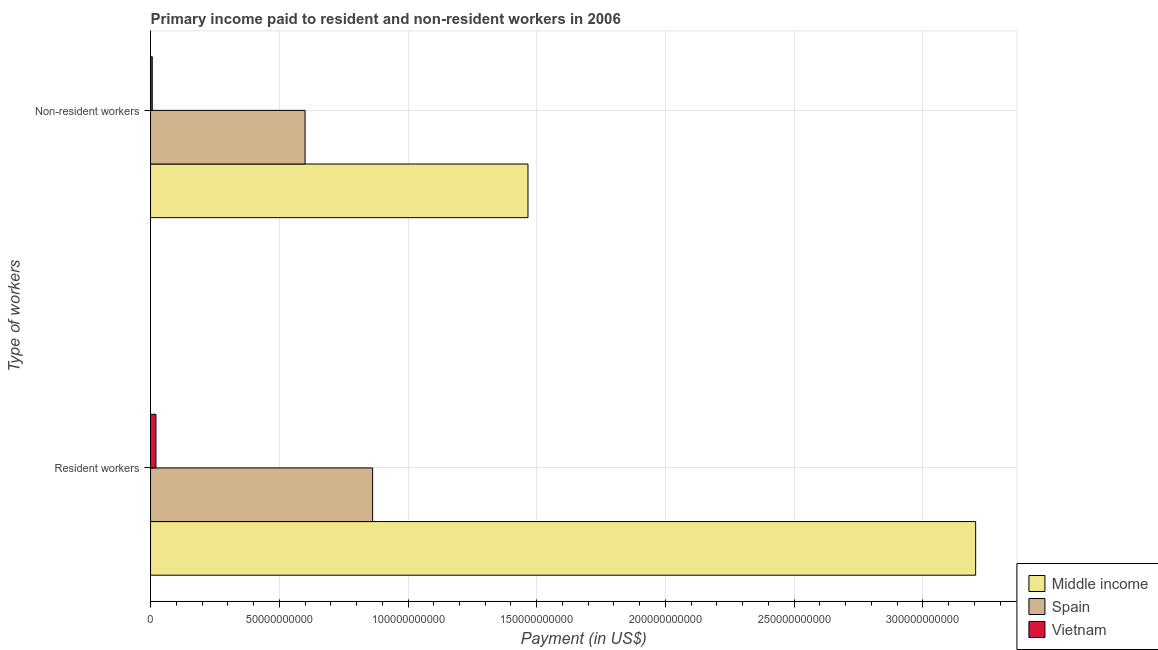How many different coloured bars are there?
Your answer should be very brief. 3. What is the label of the 1st group of bars from the top?
Your answer should be compact. Non-resident workers. What is the payment made to resident workers in Vietnam?
Your response must be concise. 2.10e+09. Across all countries, what is the maximum payment made to resident workers?
Your answer should be very brief. 3.20e+11. Across all countries, what is the minimum payment made to non-resident workers?
Offer a terse response. 6.68e+08. In which country was the payment made to resident workers minimum?
Provide a short and direct response. Vietnam. What is the total payment made to non-resident workers in the graph?
Ensure brevity in your answer.  2.07e+11. What is the difference between the payment made to resident workers in Vietnam and that in Middle income?
Provide a succinct answer. -3.18e+11. What is the difference between the payment made to non-resident workers in Spain and the payment made to resident workers in Vietnam?
Offer a terse response. 5.79e+1. What is the average payment made to resident workers per country?
Give a very brief answer. 1.36e+11. What is the difference between the payment made to non-resident workers and payment made to resident workers in Spain?
Keep it short and to the point. -2.62e+1. In how many countries, is the payment made to resident workers greater than 50000000000 US$?
Your response must be concise. 2. What is the ratio of the payment made to non-resident workers in Vietnam to that in Middle income?
Ensure brevity in your answer.  0. In how many countries, is the payment made to resident workers greater than the average payment made to resident workers taken over all countries?
Provide a short and direct response. 1. What does the 2nd bar from the bottom in Non-resident workers represents?
Provide a short and direct response. Spain. How many bars are there?
Your response must be concise. 6. Are all the bars in the graph horizontal?
Offer a terse response. Yes. How many countries are there in the graph?
Provide a short and direct response. 3. Where does the legend appear in the graph?
Provide a short and direct response. Bottom right. What is the title of the graph?
Offer a terse response. Primary income paid to resident and non-resident workers in 2006. Does "Haiti" appear as one of the legend labels in the graph?
Give a very brief answer. No. What is the label or title of the X-axis?
Your answer should be compact. Payment (in US$). What is the label or title of the Y-axis?
Keep it short and to the point. Type of workers. What is the Payment (in US$) of Middle income in Resident workers?
Offer a very short reply. 3.20e+11. What is the Payment (in US$) in Spain in Resident workers?
Offer a very short reply. 8.63e+1. What is the Payment (in US$) in Vietnam in Resident workers?
Keep it short and to the point. 2.10e+09. What is the Payment (in US$) in Middle income in Non-resident workers?
Give a very brief answer. 1.47e+11. What is the Payment (in US$) of Spain in Non-resident workers?
Offer a very short reply. 6.00e+1. What is the Payment (in US$) of Vietnam in Non-resident workers?
Give a very brief answer. 6.68e+08. Across all Type of workers, what is the maximum Payment (in US$) in Middle income?
Offer a terse response. 3.20e+11. Across all Type of workers, what is the maximum Payment (in US$) in Spain?
Give a very brief answer. 8.63e+1. Across all Type of workers, what is the maximum Payment (in US$) of Vietnam?
Your answer should be compact. 2.10e+09. Across all Type of workers, what is the minimum Payment (in US$) in Middle income?
Provide a succinct answer. 1.47e+11. Across all Type of workers, what is the minimum Payment (in US$) of Spain?
Make the answer very short. 6.00e+1. Across all Type of workers, what is the minimum Payment (in US$) in Vietnam?
Offer a very short reply. 6.68e+08. What is the total Payment (in US$) in Middle income in the graph?
Make the answer very short. 4.67e+11. What is the total Payment (in US$) in Spain in the graph?
Your response must be concise. 1.46e+11. What is the total Payment (in US$) of Vietnam in the graph?
Provide a short and direct response. 2.76e+09. What is the difference between the Payment (in US$) of Middle income in Resident workers and that in Non-resident workers?
Provide a succinct answer. 1.74e+11. What is the difference between the Payment (in US$) in Spain in Resident workers and that in Non-resident workers?
Your answer should be very brief. 2.62e+1. What is the difference between the Payment (in US$) of Vietnam in Resident workers and that in Non-resident workers?
Offer a terse response. 1.43e+09. What is the difference between the Payment (in US$) in Middle income in Resident workers and the Payment (in US$) in Spain in Non-resident workers?
Your answer should be very brief. 2.60e+11. What is the difference between the Payment (in US$) of Middle income in Resident workers and the Payment (in US$) of Vietnam in Non-resident workers?
Provide a short and direct response. 3.20e+11. What is the difference between the Payment (in US$) in Spain in Resident workers and the Payment (in US$) in Vietnam in Non-resident workers?
Your response must be concise. 8.56e+1. What is the average Payment (in US$) in Middle income per Type of workers?
Offer a terse response. 2.34e+11. What is the average Payment (in US$) of Spain per Type of workers?
Ensure brevity in your answer.  7.31e+1. What is the average Payment (in US$) in Vietnam per Type of workers?
Offer a terse response. 1.38e+09. What is the difference between the Payment (in US$) in Middle income and Payment (in US$) in Spain in Resident workers?
Give a very brief answer. 2.34e+11. What is the difference between the Payment (in US$) in Middle income and Payment (in US$) in Vietnam in Resident workers?
Your response must be concise. 3.18e+11. What is the difference between the Payment (in US$) of Spain and Payment (in US$) of Vietnam in Resident workers?
Your answer should be very brief. 8.42e+1. What is the difference between the Payment (in US$) in Middle income and Payment (in US$) in Spain in Non-resident workers?
Provide a succinct answer. 8.66e+1. What is the difference between the Payment (in US$) in Middle income and Payment (in US$) in Vietnam in Non-resident workers?
Offer a very short reply. 1.46e+11. What is the difference between the Payment (in US$) in Spain and Payment (in US$) in Vietnam in Non-resident workers?
Offer a terse response. 5.94e+1. What is the ratio of the Payment (in US$) in Middle income in Resident workers to that in Non-resident workers?
Your answer should be very brief. 2.19. What is the ratio of the Payment (in US$) of Spain in Resident workers to that in Non-resident workers?
Offer a very short reply. 1.44. What is the ratio of the Payment (in US$) in Vietnam in Resident workers to that in Non-resident workers?
Provide a short and direct response. 3.14. What is the difference between the highest and the second highest Payment (in US$) of Middle income?
Offer a very short reply. 1.74e+11. What is the difference between the highest and the second highest Payment (in US$) in Spain?
Offer a very short reply. 2.62e+1. What is the difference between the highest and the second highest Payment (in US$) in Vietnam?
Offer a very short reply. 1.43e+09. What is the difference between the highest and the lowest Payment (in US$) of Middle income?
Ensure brevity in your answer.  1.74e+11. What is the difference between the highest and the lowest Payment (in US$) in Spain?
Provide a succinct answer. 2.62e+1. What is the difference between the highest and the lowest Payment (in US$) in Vietnam?
Offer a very short reply. 1.43e+09. 